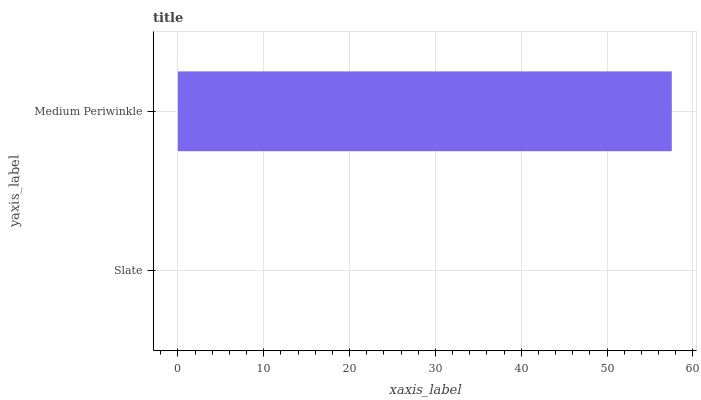Is Slate the minimum?
Answer yes or no. Yes. Is Medium Periwinkle the maximum?
Answer yes or no. Yes. Is Medium Periwinkle the minimum?
Answer yes or no. No. Is Medium Periwinkle greater than Slate?
Answer yes or no. Yes. Is Slate less than Medium Periwinkle?
Answer yes or no. Yes. Is Slate greater than Medium Periwinkle?
Answer yes or no. No. Is Medium Periwinkle less than Slate?
Answer yes or no. No. Is Medium Periwinkle the high median?
Answer yes or no. Yes. Is Slate the low median?
Answer yes or no. Yes. Is Slate the high median?
Answer yes or no. No. Is Medium Periwinkle the low median?
Answer yes or no. No. 